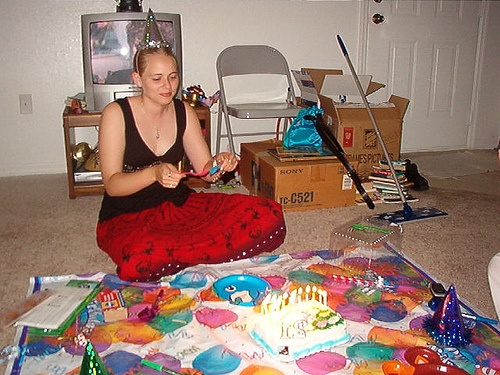Describe the objects in this image and their specific colors. I can see people in darkgray, brown, maroon, black, and salmon tones, chair in darkgray, gray, and lightgray tones, tv in darkgray, gray, and lightgray tones, cake in darkgray, ivory, turquoise, khaki, and tan tones, and spoon in darkgray, brown, red, maroon, and salmon tones in this image. 